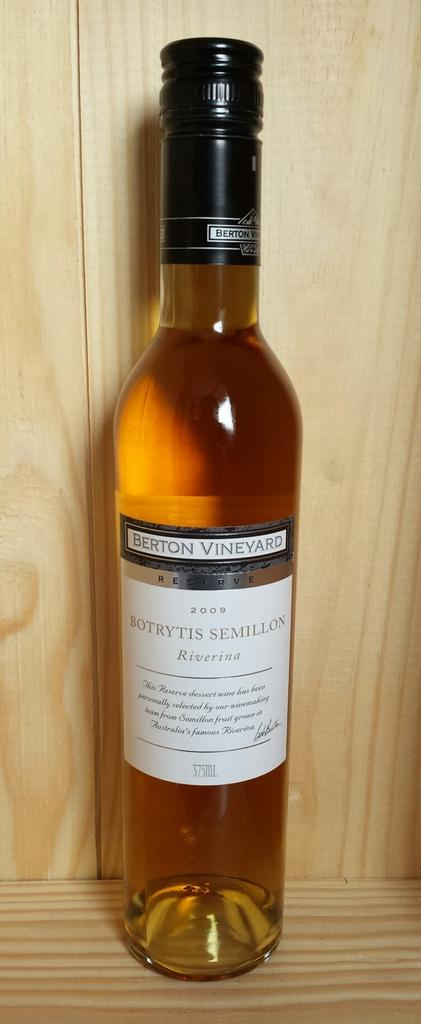What object is present in the image? There is a glass bottle in the image. Can you see any seashore or night scenes in the image? No, there is no seashore or night scene present in the image; it only features a glass bottle. Is the glass bottle placed on a tray in the image? The provided facts do not mention a tray, so it cannot be determined if the glass bottle is placed on a tray in the image. 